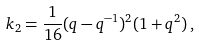<formula> <loc_0><loc_0><loc_500><loc_500>k _ { 2 } = \frac { 1 } { 1 6 } ( q - q ^ { - 1 } ) ^ { 2 } ( 1 + q ^ { 2 } ) \, ,</formula> 